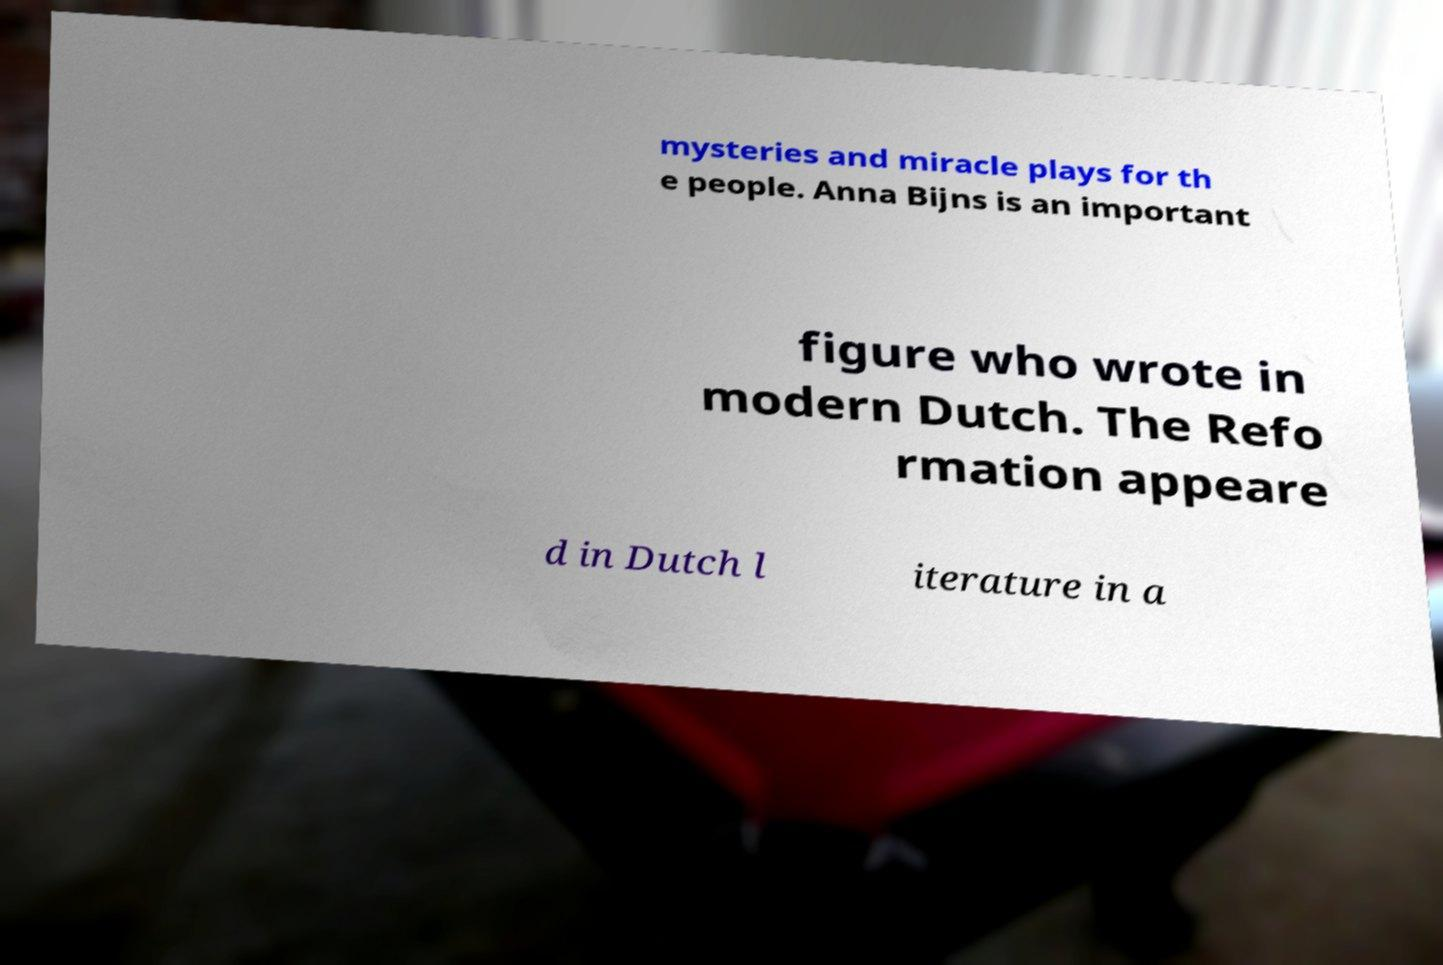I need the written content from this picture converted into text. Can you do that? mysteries and miracle plays for th e people. Anna Bijns is an important figure who wrote in modern Dutch. The Refo rmation appeare d in Dutch l iterature in a 